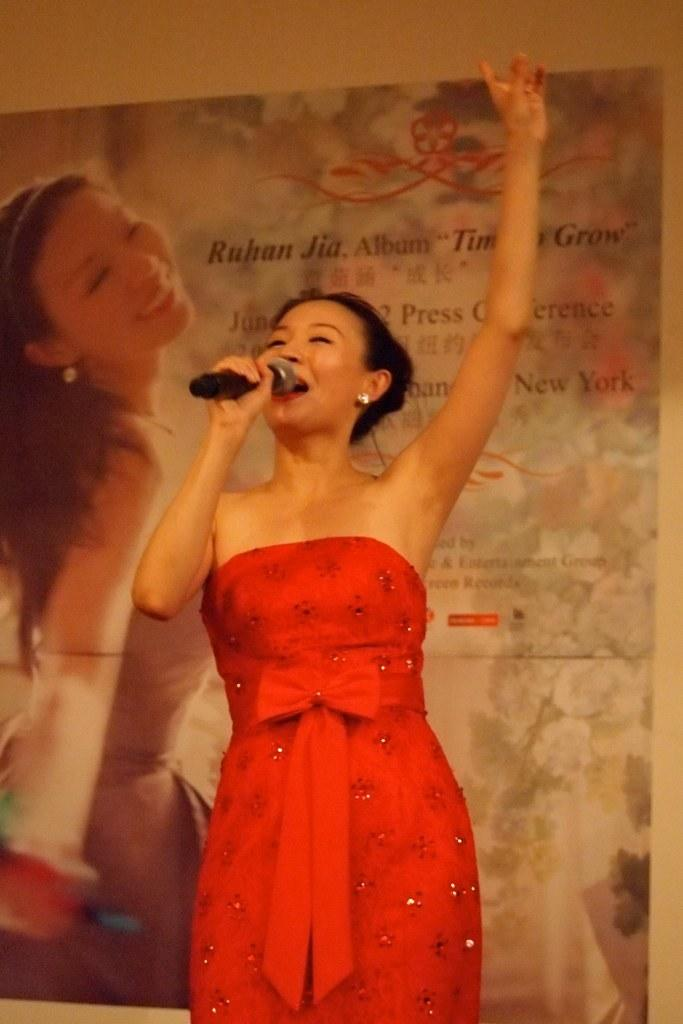Who is the main subject in the image? There is a woman in the image. What is the woman holding in the image? The woman is holding a microphone. What else can be seen in the image besides the woman? There is a banner in the image. What type of worm can be seen crawling on the woman's shoulder in the image? There is no worm present in the image; the woman is holding a microphone and standing near a banner. 